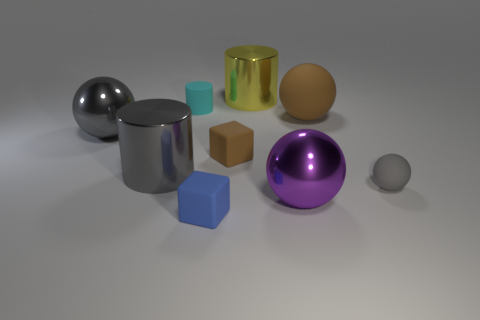Are there more tiny blue cubes behind the gray matte ball than brown matte objects?
Offer a terse response. No. Do the yellow shiny object and the brown rubber thing that is left of the yellow shiny thing have the same shape?
Give a very brief answer. No. Are any small things visible?
Your answer should be compact. Yes. How many big objects are either cyan things or blocks?
Provide a succinct answer. 0. Are there more yellow metal cylinders that are left of the yellow metallic cylinder than small brown objects that are right of the tiny sphere?
Your answer should be very brief. No. Is the large gray sphere made of the same material as the gray thing that is to the right of the yellow cylinder?
Your answer should be very brief. No. The rubber cylinder has what color?
Keep it short and to the point. Cyan. There is a small matte thing that is to the right of the purple object; what is its shape?
Offer a very short reply. Sphere. How many cyan things are tiny objects or shiny balls?
Give a very brief answer. 1. The other cylinder that is made of the same material as the gray cylinder is what color?
Your answer should be very brief. Yellow. 